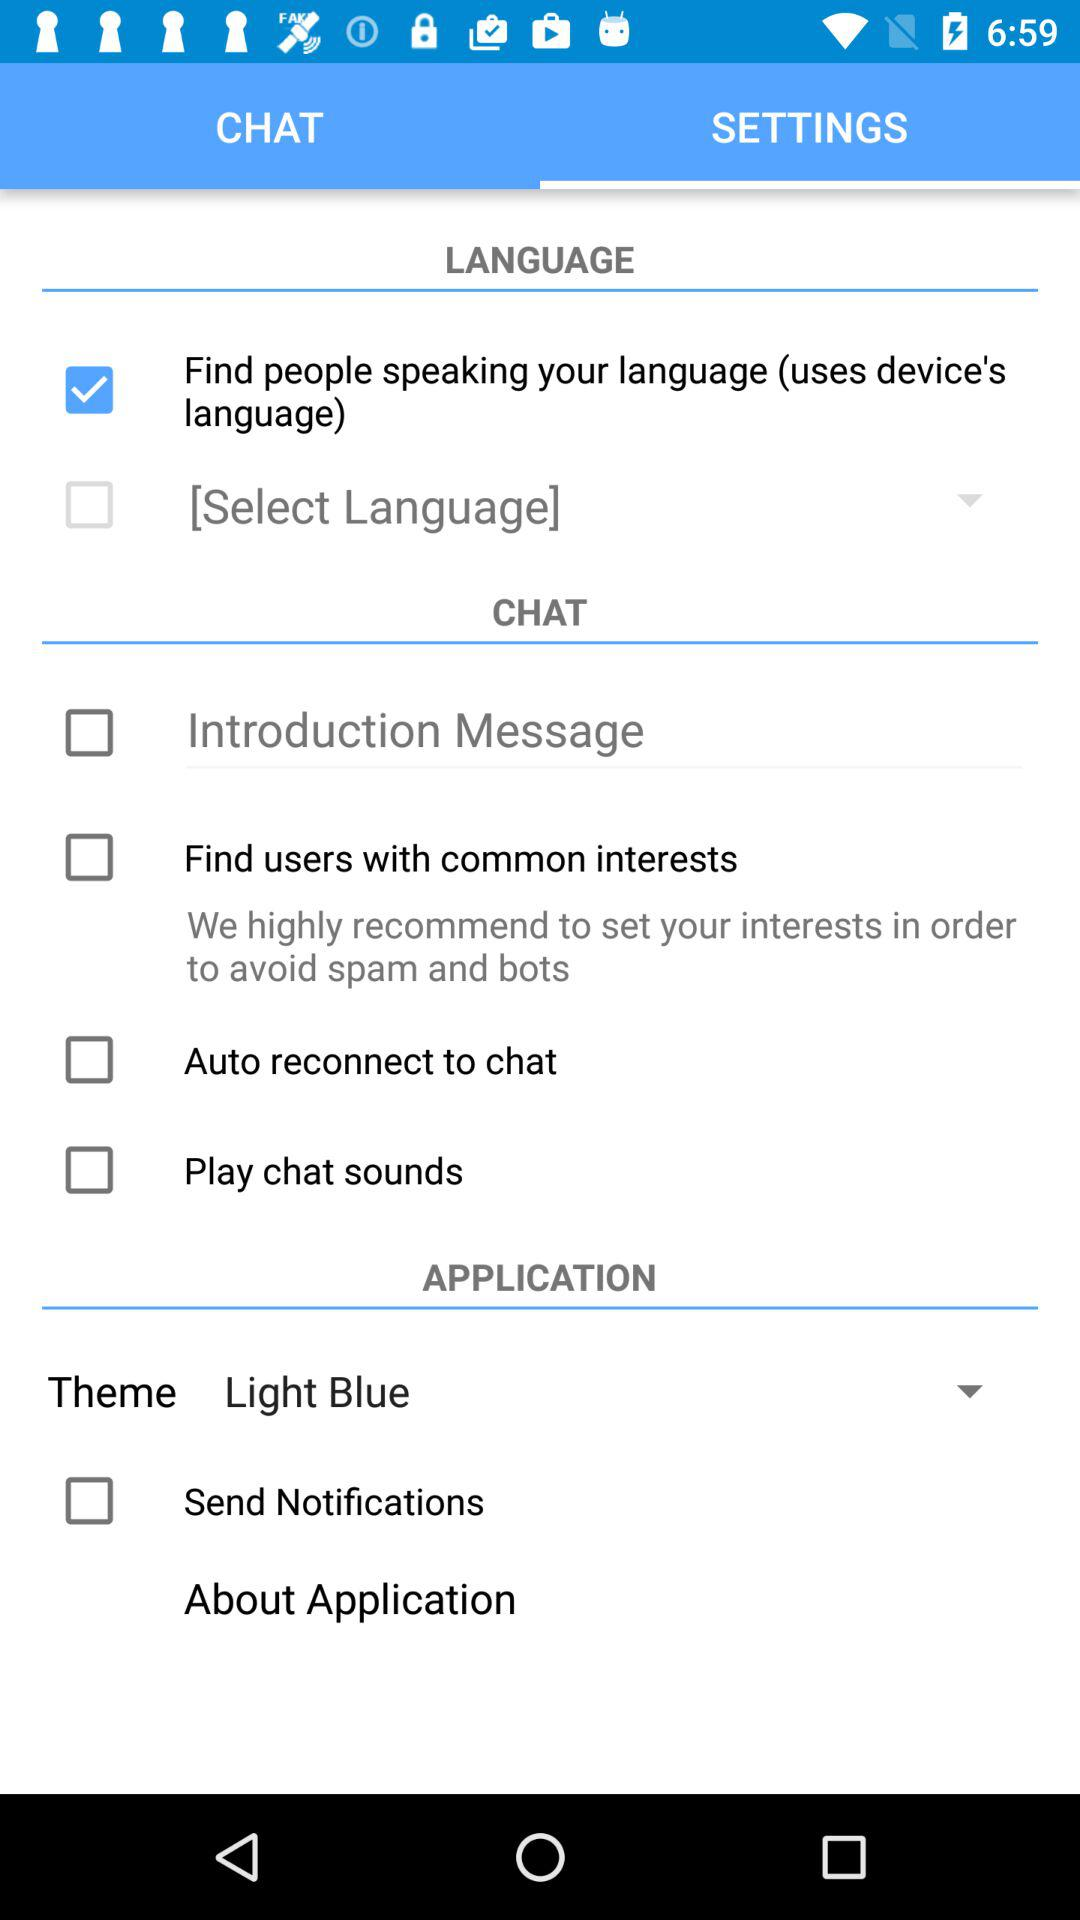Which theme color is selected? The selected theme color is light blue. 